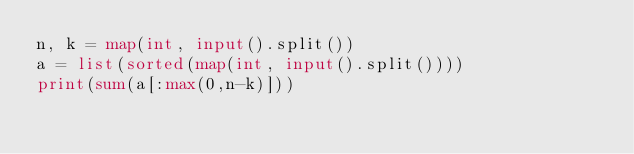<code> <loc_0><loc_0><loc_500><loc_500><_Python_>n, k = map(int, input().split())
a = list(sorted(map(int, input().split())))
print(sum(a[:max(0,n-k)]))</code> 